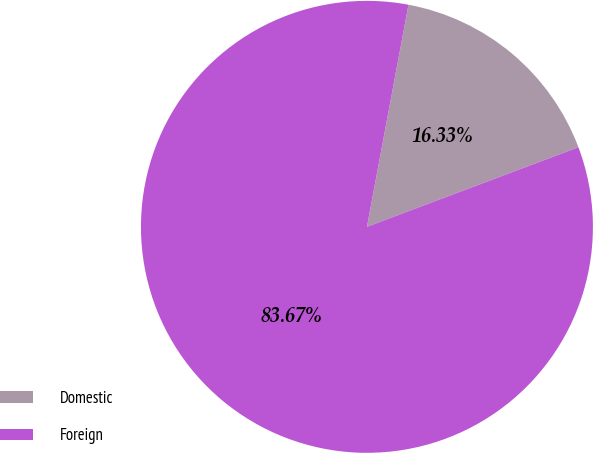Convert chart to OTSL. <chart><loc_0><loc_0><loc_500><loc_500><pie_chart><fcel>Domestic<fcel>Foreign<nl><fcel>16.33%<fcel>83.67%<nl></chart> 